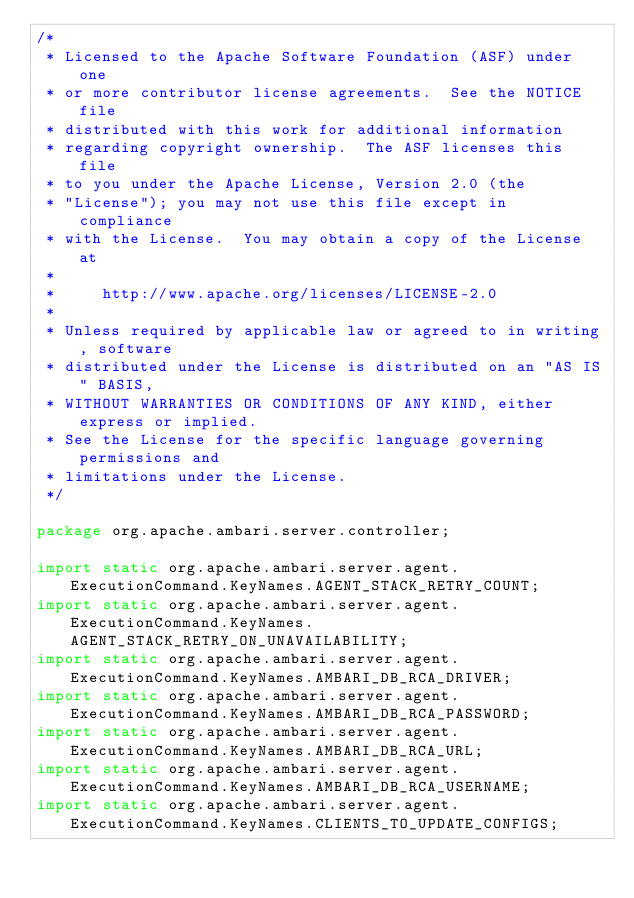<code> <loc_0><loc_0><loc_500><loc_500><_Java_>/*
 * Licensed to the Apache Software Foundation (ASF) under one
 * or more contributor license agreements.  See the NOTICE file
 * distributed with this work for additional information
 * regarding copyright ownership.  The ASF licenses this file
 * to you under the Apache License, Version 2.0 (the
 * "License"); you may not use this file except in compliance
 * with the License.  You may obtain a copy of the License at
 *
 *     http://www.apache.org/licenses/LICENSE-2.0
 *
 * Unless required by applicable law or agreed to in writing, software
 * distributed under the License is distributed on an "AS IS" BASIS,
 * WITHOUT WARRANTIES OR CONDITIONS OF ANY KIND, either express or implied.
 * See the License for the specific language governing permissions and
 * limitations under the License.
 */

package org.apache.ambari.server.controller;

import static org.apache.ambari.server.agent.ExecutionCommand.KeyNames.AGENT_STACK_RETRY_COUNT;
import static org.apache.ambari.server.agent.ExecutionCommand.KeyNames.AGENT_STACK_RETRY_ON_UNAVAILABILITY;
import static org.apache.ambari.server.agent.ExecutionCommand.KeyNames.AMBARI_DB_RCA_DRIVER;
import static org.apache.ambari.server.agent.ExecutionCommand.KeyNames.AMBARI_DB_RCA_PASSWORD;
import static org.apache.ambari.server.agent.ExecutionCommand.KeyNames.AMBARI_DB_RCA_URL;
import static org.apache.ambari.server.agent.ExecutionCommand.KeyNames.AMBARI_DB_RCA_USERNAME;
import static org.apache.ambari.server.agent.ExecutionCommand.KeyNames.CLIENTS_TO_UPDATE_CONFIGS;</code> 